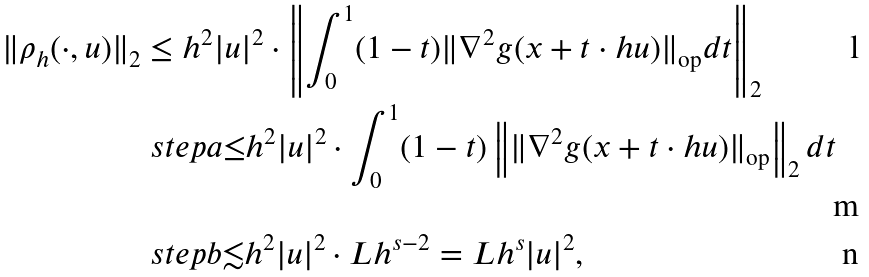<formula> <loc_0><loc_0><loc_500><loc_500>\| \rho _ { h } ( \cdot , u ) \| _ { 2 } & \leq h ^ { 2 } | u | ^ { 2 } \cdot \left \| \int _ { 0 } ^ { 1 } ( 1 - t ) \| \nabla ^ { 2 } g ( x + t \cdot h u ) \| _ { \text {op} } d t \right \| _ { 2 } \\ & \ s t e p a { \leq } h ^ { 2 } | u | ^ { 2 } \cdot \int _ { 0 } ^ { 1 } ( 1 - t ) \left \| \| \nabla ^ { 2 } g ( x + t \cdot h u ) \| _ { \text {op} } \right \| _ { 2 } d t \\ & \ s t e p b { \lesssim } h ^ { 2 } | u | ^ { 2 } \cdot L h ^ { s - 2 } = L h ^ { s } | u | ^ { 2 } ,</formula> 